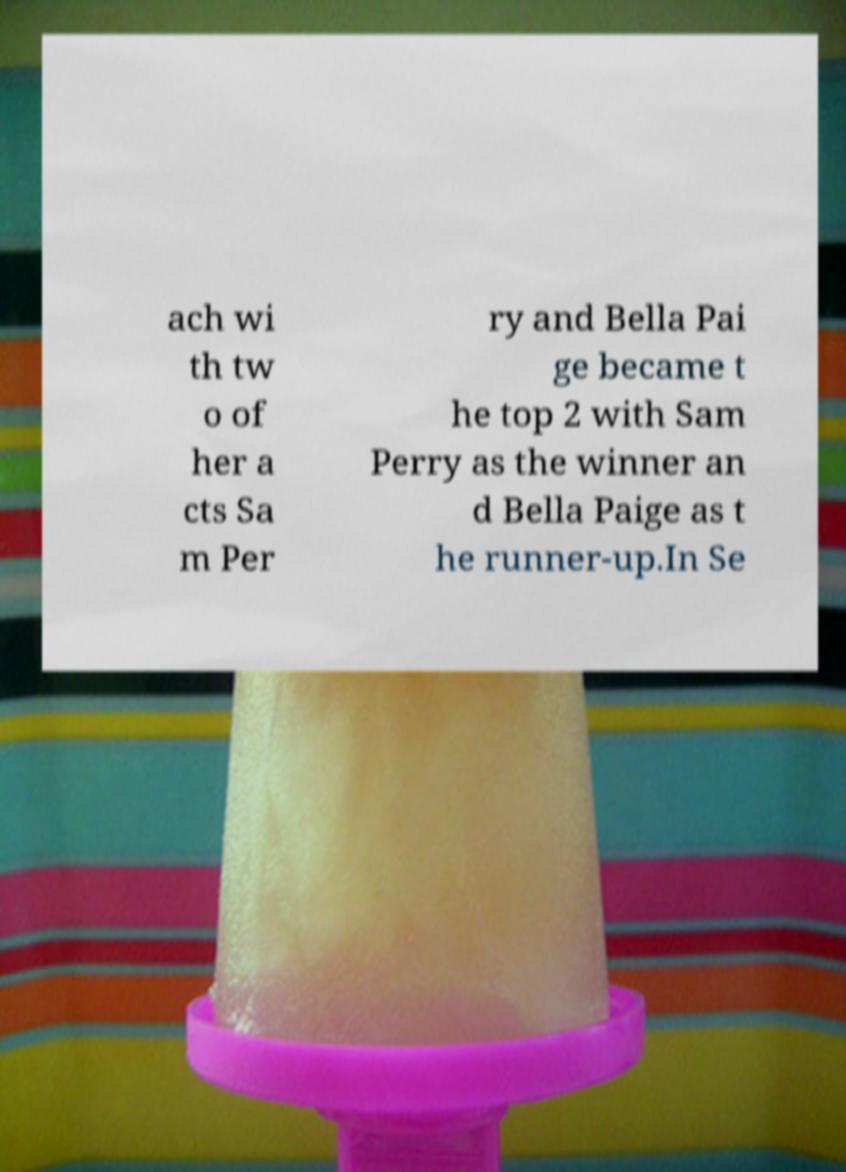For documentation purposes, I need the text within this image transcribed. Could you provide that? ach wi th tw o of her a cts Sa m Per ry and Bella Pai ge became t he top 2 with Sam Perry as the winner an d Bella Paige as t he runner-up.In Se 